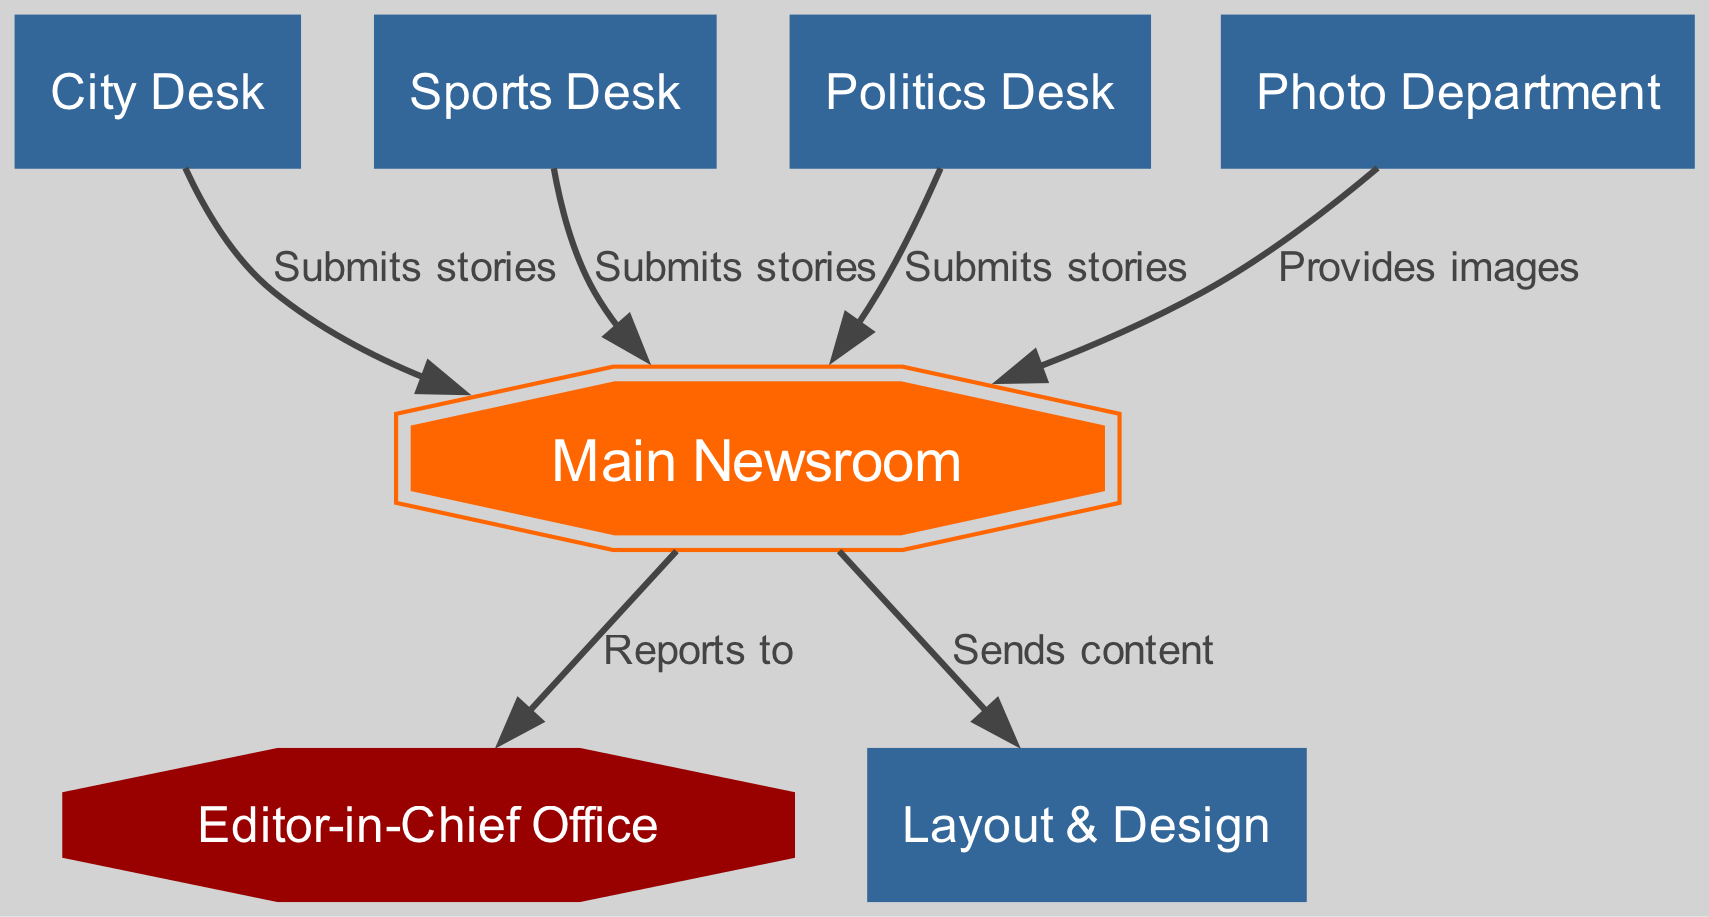What is the main area of the newsroom diagram? The main area is labeled "Main Newsroom," which serves as the central hub for other departments and interactions. This is confirmed by its position and the defined label in the diagram.
Answer: Main Newsroom How many departments submit stories to the newsroom? The diagram shows three specific departments that submit stories: City Desk, Sports Desk, and Politics Desk. Count the edges leading from these departments to the newsroom to get the total.
Answer: 3 What label is given to the office of the Editor-in-Chief? The office for the Editor-in-Chief is labeled "Editor-in-Chief Office," as indicated in the diagram’s node labels.
Answer: Editor-in-Chief Office Which department provides images directly to the newsroom? The Photo Department is indicated as providing images to the newsroom, as shown by the specific edge connecting the Photo Department to the newsroom labeled "Provides images."
Answer: Photo Department What is the primary destination for the content sent from the newsroom? The content sent from the newsroom primarily goes to the Layout & Design department, as indicated in the diagram by the edge labeled "Sends content."
Answer: Layout & Design Which department has a direct reporting line to the Editor-in-Chief? The diagram shows that all activities in the newsroom report to the Editor-in-Chief Office, connected by the edge labeled "Reports to."
Answer: Main Newsroom How many interactions are shown between the newsroom and other departments? The diagram contains a total of five interactions represented by the edges leading to and from the newsroom: three submissions of stories, image provision, and content sending.
Answer: 5 What shape is assigned to the Photo Department in the diagram? The Photo Department is represented as a standard rectangular box shape, which is consistent across other departmental nodes, indicating a typical department layout.
Answer: Box What is the relationship type between the Sports Desk and the newsroom? The relationship type to the newsroom from the Sports Desk is labeled "Submits stories," which specifies the nature of interaction in the diagram.
Answer: Submits stories 